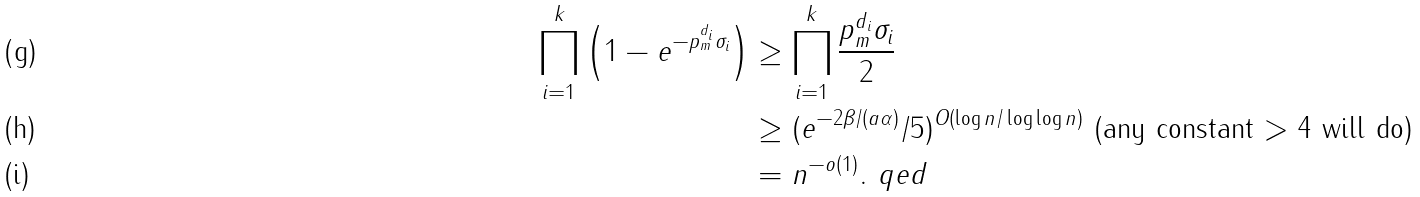Convert formula to latex. <formula><loc_0><loc_0><loc_500><loc_500>\prod _ { i = 1 } ^ { k } \left ( 1 - e ^ { - p _ { m } ^ { d _ { i } } \sigma _ { i } } \right ) & \geq \prod _ { i = 1 } ^ { k } \frac { p _ { m } ^ { d _ { i } } \sigma _ { i } } 2 \\ & \geq ( e ^ { - 2 \beta / ( a \alpha ) } / 5 ) ^ { O ( \log n / \log \log n ) } \text { (any constant $> 4$ will do)} \\ & = n ^ { - o ( 1 ) } . \ q e d</formula> 